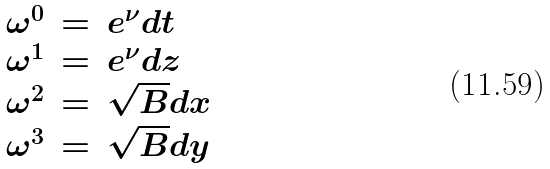Convert formula to latex. <formula><loc_0><loc_0><loc_500><loc_500>\begin{array} { l l l l } { \omega } ^ { 0 } & = & e ^ { \nu } d t \\ { \omega } ^ { 1 } & = & e ^ { \nu } d z \\ { \omega } ^ { 2 } & = & \sqrt { B } d x \\ { \omega } ^ { 3 } & = & \sqrt { B } d y \\ \end{array}</formula> 